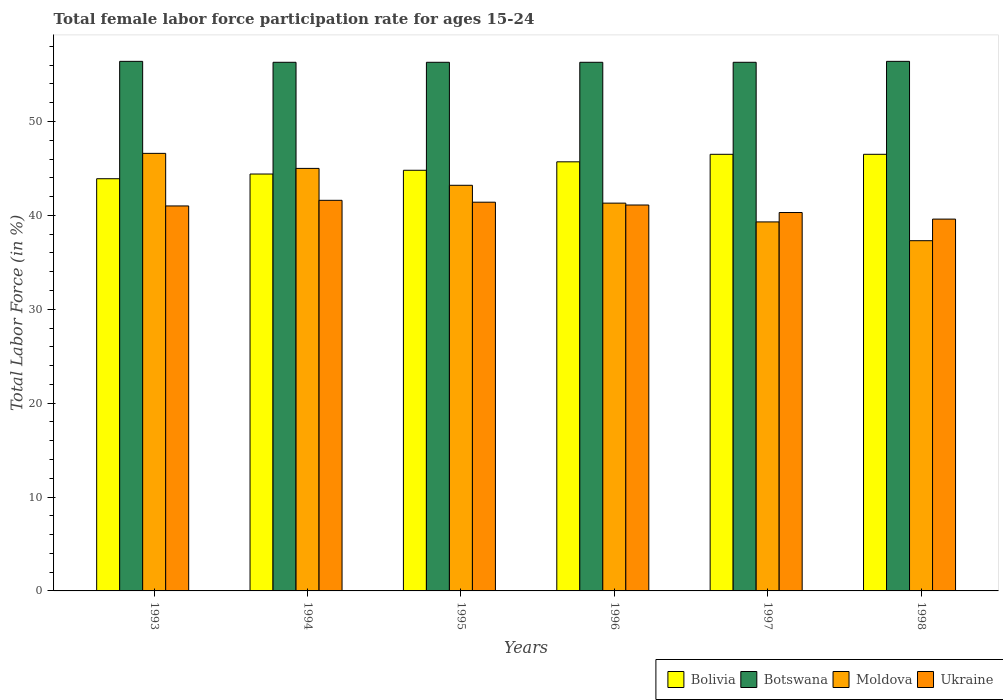How many bars are there on the 4th tick from the left?
Make the answer very short. 4. What is the female labor force participation rate in Ukraine in 1998?
Your response must be concise. 39.6. Across all years, what is the maximum female labor force participation rate in Moldova?
Provide a short and direct response. 46.6. Across all years, what is the minimum female labor force participation rate in Ukraine?
Your answer should be compact. 39.6. What is the total female labor force participation rate in Ukraine in the graph?
Offer a very short reply. 245. What is the difference between the female labor force participation rate in Bolivia in 1998 and the female labor force participation rate in Botswana in 1994?
Make the answer very short. -9.8. What is the average female labor force participation rate in Botswana per year?
Your answer should be compact. 56.33. In the year 1993, what is the difference between the female labor force participation rate in Bolivia and female labor force participation rate in Botswana?
Keep it short and to the point. -12.5. What is the ratio of the female labor force participation rate in Bolivia in 1993 to that in 1998?
Ensure brevity in your answer.  0.94. Is the female labor force participation rate in Ukraine in 1994 less than that in 1995?
Your response must be concise. No. Is the difference between the female labor force participation rate in Bolivia in 1995 and 1996 greater than the difference between the female labor force participation rate in Botswana in 1995 and 1996?
Your response must be concise. No. What is the difference between the highest and the second highest female labor force participation rate in Moldova?
Offer a terse response. 1.6. What is the difference between the highest and the lowest female labor force participation rate in Bolivia?
Offer a terse response. 2.6. Is the sum of the female labor force participation rate in Botswana in 1994 and 1998 greater than the maximum female labor force participation rate in Ukraine across all years?
Ensure brevity in your answer.  Yes. What does the 3rd bar from the left in 1993 represents?
Keep it short and to the point. Moldova. What does the 3rd bar from the right in 1996 represents?
Offer a terse response. Botswana. Is it the case that in every year, the sum of the female labor force participation rate in Botswana and female labor force participation rate in Moldova is greater than the female labor force participation rate in Ukraine?
Your answer should be very brief. Yes. How many bars are there?
Your answer should be very brief. 24. Are all the bars in the graph horizontal?
Your response must be concise. No. How many years are there in the graph?
Ensure brevity in your answer.  6. What is the title of the graph?
Provide a short and direct response. Total female labor force participation rate for ages 15-24. What is the label or title of the X-axis?
Provide a succinct answer. Years. What is the label or title of the Y-axis?
Provide a succinct answer. Total Labor Force (in %). What is the Total Labor Force (in %) of Bolivia in 1993?
Your answer should be very brief. 43.9. What is the Total Labor Force (in %) of Botswana in 1993?
Keep it short and to the point. 56.4. What is the Total Labor Force (in %) of Moldova in 1993?
Your answer should be compact. 46.6. What is the Total Labor Force (in %) of Bolivia in 1994?
Ensure brevity in your answer.  44.4. What is the Total Labor Force (in %) of Botswana in 1994?
Provide a short and direct response. 56.3. What is the Total Labor Force (in %) in Ukraine in 1994?
Keep it short and to the point. 41.6. What is the Total Labor Force (in %) in Bolivia in 1995?
Offer a very short reply. 44.8. What is the Total Labor Force (in %) of Botswana in 1995?
Give a very brief answer. 56.3. What is the Total Labor Force (in %) of Moldova in 1995?
Provide a succinct answer. 43.2. What is the Total Labor Force (in %) of Ukraine in 1995?
Your answer should be compact. 41.4. What is the Total Labor Force (in %) of Bolivia in 1996?
Make the answer very short. 45.7. What is the Total Labor Force (in %) in Botswana in 1996?
Provide a short and direct response. 56.3. What is the Total Labor Force (in %) in Moldova in 1996?
Make the answer very short. 41.3. What is the Total Labor Force (in %) in Ukraine in 1996?
Provide a short and direct response. 41.1. What is the Total Labor Force (in %) of Bolivia in 1997?
Your response must be concise. 46.5. What is the Total Labor Force (in %) in Botswana in 1997?
Provide a succinct answer. 56.3. What is the Total Labor Force (in %) in Moldova in 1997?
Your answer should be very brief. 39.3. What is the Total Labor Force (in %) in Ukraine in 1997?
Your answer should be compact. 40.3. What is the Total Labor Force (in %) in Bolivia in 1998?
Offer a very short reply. 46.5. What is the Total Labor Force (in %) in Botswana in 1998?
Give a very brief answer. 56.4. What is the Total Labor Force (in %) of Moldova in 1998?
Keep it short and to the point. 37.3. What is the Total Labor Force (in %) in Ukraine in 1998?
Offer a terse response. 39.6. Across all years, what is the maximum Total Labor Force (in %) in Bolivia?
Your answer should be compact. 46.5. Across all years, what is the maximum Total Labor Force (in %) of Botswana?
Provide a short and direct response. 56.4. Across all years, what is the maximum Total Labor Force (in %) of Moldova?
Your answer should be compact. 46.6. Across all years, what is the maximum Total Labor Force (in %) in Ukraine?
Provide a short and direct response. 41.6. Across all years, what is the minimum Total Labor Force (in %) of Bolivia?
Give a very brief answer. 43.9. Across all years, what is the minimum Total Labor Force (in %) of Botswana?
Your response must be concise. 56.3. Across all years, what is the minimum Total Labor Force (in %) of Moldova?
Provide a succinct answer. 37.3. Across all years, what is the minimum Total Labor Force (in %) of Ukraine?
Your answer should be compact. 39.6. What is the total Total Labor Force (in %) in Bolivia in the graph?
Keep it short and to the point. 271.8. What is the total Total Labor Force (in %) in Botswana in the graph?
Keep it short and to the point. 338. What is the total Total Labor Force (in %) of Moldova in the graph?
Provide a short and direct response. 252.7. What is the total Total Labor Force (in %) in Ukraine in the graph?
Provide a succinct answer. 245. What is the difference between the Total Labor Force (in %) of Botswana in 1993 and that in 1994?
Make the answer very short. 0.1. What is the difference between the Total Labor Force (in %) in Moldova in 1993 and that in 1994?
Your response must be concise. 1.6. What is the difference between the Total Labor Force (in %) of Moldova in 1993 and that in 1995?
Your answer should be compact. 3.4. What is the difference between the Total Labor Force (in %) of Botswana in 1993 and that in 1996?
Keep it short and to the point. 0.1. What is the difference between the Total Labor Force (in %) in Moldova in 1993 and that in 1996?
Make the answer very short. 5.3. What is the difference between the Total Labor Force (in %) of Bolivia in 1993 and that in 1997?
Keep it short and to the point. -2.6. What is the difference between the Total Labor Force (in %) in Botswana in 1993 and that in 1997?
Offer a terse response. 0.1. What is the difference between the Total Labor Force (in %) in Moldova in 1993 and that in 1997?
Your response must be concise. 7.3. What is the difference between the Total Labor Force (in %) in Botswana in 1993 and that in 1998?
Provide a succinct answer. 0. What is the difference between the Total Labor Force (in %) of Ukraine in 1993 and that in 1998?
Your answer should be very brief. 1.4. What is the difference between the Total Labor Force (in %) of Bolivia in 1994 and that in 1995?
Ensure brevity in your answer.  -0.4. What is the difference between the Total Labor Force (in %) of Botswana in 1994 and that in 1995?
Provide a succinct answer. 0. What is the difference between the Total Labor Force (in %) of Moldova in 1994 and that in 1995?
Offer a very short reply. 1.8. What is the difference between the Total Labor Force (in %) of Botswana in 1994 and that in 1996?
Provide a succinct answer. 0. What is the difference between the Total Labor Force (in %) of Moldova in 1994 and that in 1996?
Your response must be concise. 3.7. What is the difference between the Total Labor Force (in %) of Ukraine in 1994 and that in 1996?
Offer a terse response. 0.5. What is the difference between the Total Labor Force (in %) of Moldova in 1994 and that in 1997?
Provide a succinct answer. 5.7. What is the difference between the Total Labor Force (in %) of Ukraine in 1994 and that in 1997?
Offer a very short reply. 1.3. What is the difference between the Total Labor Force (in %) in Bolivia in 1994 and that in 1998?
Your response must be concise. -2.1. What is the difference between the Total Labor Force (in %) in Botswana in 1994 and that in 1998?
Make the answer very short. -0.1. What is the difference between the Total Labor Force (in %) in Moldova in 1994 and that in 1998?
Make the answer very short. 7.7. What is the difference between the Total Labor Force (in %) in Ukraine in 1994 and that in 1998?
Provide a short and direct response. 2. What is the difference between the Total Labor Force (in %) in Moldova in 1995 and that in 1996?
Offer a terse response. 1.9. What is the difference between the Total Labor Force (in %) of Bolivia in 1995 and that in 1997?
Keep it short and to the point. -1.7. What is the difference between the Total Labor Force (in %) in Ukraine in 1995 and that in 1997?
Your response must be concise. 1.1. What is the difference between the Total Labor Force (in %) of Bolivia in 1995 and that in 1998?
Give a very brief answer. -1.7. What is the difference between the Total Labor Force (in %) of Moldova in 1995 and that in 1998?
Provide a succinct answer. 5.9. What is the difference between the Total Labor Force (in %) of Bolivia in 1996 and that in 1997?
Give a very brief answer. -0.8. What is the difference between the Total Labor Force (in %) in Botswana in 1996 and that in 1997?
Offer a terse response. 0. What is the difference between the Total Labor Force (in %) in Moldova in 1996 and that in 1997?
Offer a very short reply. 2. What is the difference between the Total Labor Force (in %) of Bolivia in 1996 and that in 1998?
Your answer should be compact. -0.8. What is the difference between the Total Labor Force (in %) in Moldova in 1996 and that in 1998?
Make the answer very short. 4. What is the difference between the Total Labor Force (in %) in Ukraine in 1996 and that in 1998?
Your answer should be compact. 1.5. What is the difference between the Total Labor Force (in %) in Bolivia in 1997 and that in 1998?
Make the answer very short. 0. What is the difference between the Total Labor Force (in %) in Botswana in 1997 and that in 1998?
Offer a terse response. -0.1. What is the difference between the Total Labor Force (in %) of Moldova in 1997 and that in 1998?
Make the answer very short. 2. What is the difference between the Total Labor Force (in %) in Bolivia in 1993 and the Total Labor Force (in %) in Moldova in 1994?
Provide a succinct answer. -1.1. What is the difference between the Total Labor Force (in %) in Botswana in 1993 and the Total Labor Force (in %) in Ukraine in 1994?
Ensure brevity in your answer.  14.8. What is the difference between the Total Labor Force (in %) in Moldova in 1993 and the Total Labor Force (in %) in Ukraine in 1994?
Provide a succinct answer. 5. What is the difference between the Total Labor Force (in %) in Bolivia in 1993 and the Total Labor Force (in %) in Botswana in 1995?
Offer a very short reply. -12.4. What is the difference between the Total Labor Force (in %) in Botswana in 1993 and the Total Labor Force (in %) in Moldova in 1995?
Give a very brief answer. 13.2. What is the difference between the Total Labor Force (in %) of Botswana in 1993 and the Total Labor Force (in %) of Ukraine in 1995?
Make the answer very short. 15. What is the difference between the Total Labor Force (in %) of Bolivia in 1993 and the Total Labor Force (in %) of Ukraine in 1996?
Keep it short and to the point. 2.8. What is the difference between the Total Labor Force (in %) in Botswana in 1993 and the Total Labor Force (in %) in Moldova in 1996?
Make the answer very short. 15.1. What is the difference between the Total Labor Force (in %) of Moldova in 1993 and the Total Labor Force (in %) of Ukraine in 1996?
Keep it short and to the point. 5.5. What is the difference between the Total Labor Force (in %) of Bolivia in 1993 and the Total Labor Force (in %) of Botswana in 1997?
Give a very brief answer. -12.4. What is the difference between the Total Labor Force (in %) in Bolivia in 1993 and the Total Labor Force (in %) in Moldova in 1997?
Keep it short and to the point. 4.6. What is the difference between the Total Labor Force (in %) of Bolivia in 1993 and the Total Labor Force (in %) of Ukraine in 1997?
Keep it short and to the point. 3.6. What is the difference between the Total Labor Force (in %) of Botswana in 1993 and the Total Labor Force (in %) of Moldova in 1997?
Ensure brevity in your answer.  17.1. What is the difference between the Total Labor Force (in %) in Botswana in 1993 and the Total Labor Force (in %) in Ukraine in 1997?
Ensure brevity in your answer.  16.1. What is the difference between the Total Labor Force (in %) in Bolivia in 1993 and the Total Labor Force (in %) in Botswana in 1998?
Your response must be concise. -12.5. What is the difference between the Total Labor Force (in %) in Bolivia in 1993 and the Total Labor Force (in %) in Ukraine in 1998?
Your answer should be compact. 4.3. What is the difference between the Total Labor Force (in %) in Botswana in 1993 and the Total Labor Force (in %) in Moldova in 1998?
Keep it short and to the point. 19.1. What is the difference between the Total Labor Force (in %) in Botswana in 1993 and the Total Labor Force (in %) in Ukraine in 1998?
Offer a very short reply. 16.8. What is the difference between the Total Labor Force (in %) of Moldova in 1993 and the Total Labor Force (in %) of Ukraine in 1998?
Provide a succinct answer. 7. What is the difference between the Total Labor Force (in %) in Bolivia in 1994 and the Total Labor Force (in %) in Moldova in 1995?
Keep it short and to the point. 1.2. What is the difference between the Total Labor Force (in %) in Bolivia in 1994 and the Total Labor Force (in %) in Botswana in 1996?
Offer a very short reply. -11.9. What is the difference between the Total Labor Force (in %) in Bolivia in 1994 and the Total Labor Force (in %) in Moldova in 1996?
Provide a succinct answer. 3.1. What is the difference between the Total Labor Force (in %) of Botswana in 1994 and the Total Labor Force (in %) of Moldova in 1996?
Provide a succinct answer. 15. What is the difference between the Total Labor Force (in %) of Botswana in 1994 and the Total Labor Force (in %) of Ukraine in 1996?
Your response must be concise. 15.2. What is the difference between the Total Labor Force (in %) in Bolivia in 1994 and the Total Labor Force (in %) in Ukraine in 1997?
Ensure brevity in your answer.  4.1. What is the difference between the Total Labor Force (in %) of Botswana in 1994 and the Total Labor Force (in %) of Moldova in 1997?
Offer a very short reply. 17. What is the difference between the Total Labor Force (in %) of Moldova in 1994 and the Total Labor Force (in %) of Ukraine in 1997?
Provide a succinct answer. 4.7. What is the difference between the Total Labor Force (in %) in Bolivia in 1994 and the Total Labor Force (in %) in Moldova in 1998?
Your answer should be very brief. 7.1. What is the difference between the Total Labor Force (in %) in Bolivia in 1994 and the Total Labor Force (in %) in Ukraine in 1998?
Ensure brevity in your answer.  4.8. What is the difference between the Total Labor Force (in %) of Botswana in 1994 and the Total Labor Force (in %) of Moldova in 1998?
Ensure brevity in your answer.  19. What is the difference between the Total Labor Force (in %) in Moldova in 1994 and the Total Labor Force (in %) in Ukraine in 1998?
Your answer should be compact. 5.4. What is the difference between the Total Labor Force (in %) of Bolivia in 1995 and the Total Labor Force (in %) of Moldova in 1996?
Provide a succinct answer. 3.5. What is the difference between the Total Labor Force (in %) in Bolivia in 1995 and the Total Labor Force (in %) in Ukraine in 1996?
Give a very brief answer. 3.7. What is the difference between the Total Labor Force (in %) in Botswana in 1995 and the Total Labor Force (in %) in Moldova in 1996?
Your answer should be very brief. 15. What is the difference between the Total Labor Force (in %) of Bolivia in 1995 and the Total Labor Force (in %) of Moldova in 1997?
Give a very brief answer. 5.5. What is the difference between the Total Labor Force (in %) of Bolivia in 1995 and the Total Labor Force (in %) of Ukraine in 1997?
Provide a succinct answer. 4.5. What is the difference between the Total Labor Force (in %) of Botswana in 1995 and the Total Labor Force (in %) of Moldova in 1997?
Offer a terse response. 17. What is the difference between the Total Labor Force (in %) in Bolivia in 1995 and the Total Labor Force (in %) in Botswana in 1998?
Offer a terse response. -11.6. What is the difference between the Total Labor Force (in %) in Bolivia in 1995 and the Total Labor Force (in %) in Moldova in 1998?
Your answer should be compact. 7.5. What is the difference between the Total Labor Force (in %) in Botswana in 1995 and the Total Labor Force (in %) in Moldova in 1998?
Provide a short and direct response. 19. What is the difference between the Total Labor Force (in %) of Botswana in 1995 and the Total Labor Force (in %) of Ukraine in 1998?
Provide a short and direct response. 16.7. What is the difference between the Total Labor Force (in %) in Bolivia in 1996 and the Total Labor Force (in %) in Moldova in 1997?
Offer a terse response. 6.4. What is the difference between the Total Labor Force (in %) of Bolivia in 1996 and the Total Labor Force (in %) of Ukraine in 1997?
Your response must be concise. 5.4. What is the difference between the Total Labor Force (in %) in Botswana in 1996 and the Total Labor Force (in %) in Ukraine in 1997?
Make the answer very short. 16. What is the difference between the Total Labor Force (in %) of Moldova in 1996 and the Total Labor Force (in %) of Ukraine in 1997?
Your response must be concise. 1. What is the difference between the Total Labor Force (in %) in Bolivia in 1996 and the Total Labor Force (in %) in Botswana in 1998?
Your answer should be very brief. -10.7. What is the difference between the Total Labor Force (in %) of Bolivia in 1996 and the Total Labor Force (in %) of Moldova in 1998?
Your answer should be very brief. 8.4. What is the difference between the Total Labor Force (in %) in Bolivia in 1996 and the Total Labor Force (in %) in Ukraine in 1998?
Provide a short and direct response. 6.1. What is the difference between the Total Labor Force (in %) in Botswana in 1996 and the Total Labor Force (in %) in Ukraine in 1998?
Offer a terse response. 16.7. What is the difference between the Total Labor Force (in %) of Moldova in 1996 and the Total Labor Force (in %) of Ukraine in 1998?
Offer a terse response. 1.7. What is the difference between the Total Labor Force (in %) of Bolivia in 1997 and the Total Labor Force (in %) of Moldova in 1998?
Provide a succinct answer. 9.2. What is the difference between the Total Labor Force (in %) in Bolivia in 1997 and the Total Labor Force (in %) in Ukraine in 1998?
Make the answer very short. 6.9. What is the difference between the Total Labor Force (in %) in Botswana in 1997 and the Total Labor Force (in %) in Moldova in 1998?
Provide a succinct answer. 19. What is the difference between the Total Labor Force (in %) in Botswana in 1997 and the Total Labor Force (in %) in Ukraine in 1998?
Offer a very short reply. 16.7. What is the difference between the Total Labor Force (in %) in Moldova in 1997 and the Total Labor Force (in %) in Ukraine in 1998?
Your answer should be compact. -0.3. What is the average Total Labor Force (in %) in Bolivia per year?
Offer a terse response. 45.3. What is the average Total Labor Force (in %) in Botswana per year?
Give a very brief answer. 56.33. What is the average Total Labor Force (in %) in Moldova per year?
Offer a very short reply. 42.12. What is the average Total Labor Force (in %) of Ukraine per year?
Provide a succinct answer. 40.83. In the year 1993, what is the difference between the Total Labor Force (in %) in Bolivia and Total Labor Force (in %) in Botswana?
Provide a succinct answer. -12.5. In the year 1993, what is the difference between the Total Labor Force (in %) in Bolivia and Total Labor Force (in %) in Ukraine?
Your answer should be compact. 2.9. In the year 1994, what is the difference between the Total Labor Force (in %) of Bolivia and Total Labor Force (in %) of Botswana?
Provide a short and direct response. -11.9. In the year 1994, what is the difference between the Total Labor Force (in %) in Bolivia and Total Labor Force (in %) in Moldova?
Your response must be concise. -0.6. In the year 1994, what is the difference between the Total Labor Force (in %) in Botswana and Total Labor Force (in %) in Ukraine?
Provide a short and direct response. 14.7. In the year 1995, what is the difference between the Total Labor Force (in %) in Bolivia and Total Labor Force (in %) in Botswana?
Make the answer very short. -11.5. In the year 1995, what is the difference between the Total Labor Force (in %) of Bolivia and Total Labor Force (in %) of Moldova?
Keep it short and to the point. 1.6. In the year 1995, what is the difference between the Total Labor Force (in %) in Botswana and Total Labor Force (in %) in Ukraine?
Ensure brevity in your answer.  14.9. In the year 1995, what is the difference between the Total Labor Force (in %) of Moldova and Total Labor Force (in %) of Ukraine?
Offer a terse response. 1.8. In the year 1996, what is the difference between the Total Labor Force (in %) in Bolivia and Total Labor Force (in %) in Moldova?
Keep it short and to the point. 4.4. In the year 1997, what is the difference between the Total Labor Force (in %) in Bolivia and Total Labor Force (in %) in Botswana?
Offer a terse response. -9.8. In the year 1997, what is the difference between the Total Labor Force (in %) in Bolivia and Total Labor Force (in %) in Moldova?
Make the answer very short. 7.2. In the year 1997, what is the difference between the Total Labor Force (in %) in Bolivia and Total Labor Force (in %) in Ukraine?
Provide a short and direct response. 6.2. In the year 1997, what is the difference between the Total Labor Force (in %) in Botswana and Total Labor Force (in %) in Moldova?
Your response must be concise. 17. In the year 1997, what is the difference between the Total Labor Force (in %) in Botswana and Total Labor Force (in %) in Ukraine?
Give a very brief answer. 16. In the year 1997, what is the difference between the Total Labor Force (in %) of Moldova and Total Labor Force (in %) of Ukraine?
Your answer should be very brief. -1. In the year 1998, what is the difference between the Total Labor Force (in %) in Bolivia and Total Labor Force (in %) in Moldova?
Give a very brief answer. 9.2. In the year 1998, what is the difference between the Total Labor Force (in %) of Moldova and Total Labor Force (in %) of Ukraine?
Provide a short and direct response. -2.3. What is the ratio of the Total Labor Force (in %) in Bolivia in 1993 to that in 1994?
Offer a very short reply. 0.99. What is the ratio of the Total Labor Force (in %) of Moldova in 1993 to that in 1994?
Provide a short and direct response. 1.04. What is the ratio of the Total Labor Force (in %) in Ukraine in 1993 to that in 1994?
Keep it short and to the point. 0.99. What is the ratio of the Total Labor Force (in %) of Bolivia in 1993 to that in 1995?
Give a very brief answer. 0.98. What is the ratio of the Total Labor Force (in %) in Botswana in 1993 to that in 1995?
Offer a very short reply. 1. What is the ratio of the Total Labor Force (in %) of Moldova in 1993 to that in 1995?
Provide a succinct answer. 1.08. What is the ratio of the Total Labor Force (in %) of Ukraine in 1993 to that in 1995?
Offer a terse response. 0.99. What is the ratio of the Total Labor Force (in %) in Bolivia in 1993 to that in 1996?
Give a very brief answer. 0.96. What is the ratio of the Total Labor Force (in %) of Botswana in 1993 to that in 1996?
Offer a terse response. 1. What is the ratio of the Total Labor Force (in %) in Moldova in 1993 to that in 1996?
Your answer should be very brief. 1.13. What is the ratio of the Total Labor Force (in %) in Bolivia in 1993 to that in 1997?
Ensure brevity in your answer.  0.94. What is the ratio of the Total Labor Force (in %) in Botswana in 1993 to that in 1997?
Make the answer very short. 1. What is the ratio of the Total Labor Force (in %) of Moldova in 1993 to that in 1997?
Ensure brevity in your answer.  1.19. What is the ratio of the Total Labor Force (in %) of Ukraine in 1993 to that in 1997?
Ensure brevity in your answer.  1.02. What is the ratio of the Total Labor Force (in %) in Bolivia in 1993 to that in 1998?
Your answer should be compact. 0.94. What is the ratio of the Total Labor Force (in %) of Moldova in 1993 to that in 1998?
Keep it short and to the point. 1.25. What is the ratio of the Total Labor Force (in %) in Ukraine in 1993 to that in 1998?
Offer a terse response. 1.04. What is the ratio of the Total Labor Force (in %) in Bolivia in 1994 to that in 1995?
Offer a terse response. 0.99. What is the ratio of the Total Labor Force (in %) in Botswana in 1994 to that in 1995?
Provide a succinct answer. 1. What is the ratio of the Total Labor Force (in %) of Moldova in 1994 to that in 1995?
Give a very brief answer. 1.04. What is the ratio of the Total Labor Force (in %) of Ukraine in 1994 to that in 1995?
Provide a succinct answer. 1. What is the ratio of the Total Labor Force (in %) of Bolivia in 1994 to that in 1996?
Provide a short and direct response. 0.97. What is the ratio of the Total Labor Force (in %) of Botswana in 1994 to that in 1996?
Give a very brief answer. 1. What is the ratio of the Total Labor Force (in %) of Moldova in 1994 to that in 1996?
Make the answer very short. 1.09. What is the ratio of the Total Labor Force (in %) of Ukraine in 1994 to that in 1996?
Your answer should be very brief. 1.01. What is the ratio of the Total Labor Force (in %) in Bolivia in 1994 to that in 1997?
Offer a very short reply. 0.95. What is the ratio of the Total Labor Force (in %) of Moldova in 1994 to that in 1997?
Provide a succinct answer. 1.15. What is the ratio of the Total Labor Force (in %) of Ukraine in 1994 to that in 1997?
Ensure brevity in your answer.  1.03. What is the ratio of the Total Labor Force (in %) of Bolivia in 1994 to that in 1998?
Offer a very short reply. 0.95. What is the ratio of the Total Labor Force (in %) of Botswana in 1994 to that in 1998?
Ensure brevity in your answer.  1. What is the ratio of the Total Labor Force (in %) of Moldova in 1994 to that in 1998?
Offer a very short reply. 1.21. What is the ratio of the Total Labor Force (in %) of Ukraine in 1994 to that in 1998?
Your answer should be very brief. 1.05. What is the ratio of the Total Labor Force (in %) in Bolivia in 1995 to that in 1996?
Ensure brevity in your answer.  0.98. What is the ratio of the Total Labor Force (in %) in Botswana in 1995 to that in 1996?
Your response must be concise. 1. What is the ratio of the Total Labor Force (in %) in Moldova in 1995 to that in 1996?
Provide a succinct answer. 1.05. What is the ratio of the Total Labor Force (in %) of Ukraine in 1995 to that in 1996?
Your response must be concise. 1.01. What is the ratio of the Total Labor Force (in %) of Bolivia in 1995 to that in 1997?
Make the answer very short. 0.96. What is the ratio of the Total Labor Force (in %) of Moldova in 1995 to that in 1997?
Provide a short and direct response. 1.1. What is the ratio of the Total Labor Force (in %) in Ukraine in 1995 to that in 1997?
Provide a succinct answer. 1.03. What is the ratio of the Total Labor Force (in %) of Bolivia in 1995 to that in 1998?
Your response must be concise. 0.96. What is the ratio of the Total Labor Force (in %) of Botswana in 1995 to that in 1998?
Your answer should be very brief. 1. What is the ratio of the Total Labor Force (in %) in Moldova in 1995 to that in 1998?
Offer a very short reply. 1.16. What is the ratio of the Total Labor Force (in %) in Ukraine in 1995 to that in 1998?
Ensure brevity in your answer.  1.05. What is the ratio of the Total Labor Force (in %) in Bolivia in 1996 to that in 1997?
Keep it short and to the point. 0.98. What is the ratio of the Total Labor Force (in %) of Botswana in 1996 to that in 1997?
Your answer should be compact. 1. What is the ratio of the Total Labor Force (in %) in Moldova in 1996 to that in 1997?
Your answer should be compact. 1.05. What is the ratio of the Total Labor Force (in %) in Ukraine in 1996 to that in 1997?
Provide a short and direct response. 1.02. What is the ratio of the Total Labor Force (in %) in Bolivia in 1996 to that in 1998?
Provide a succinct answer. 0.98. What is the ratio of the Total Labor Force (in %) of Botswana in 1996 to that in 1998?
Keep it short and to the point. 1. What is the ratio of the Total Labor Force (in %) of Moldova in 1996 to that in 1998?
Offer a very short reply. 1.11. What is the ratio of the Total Labor Force (in %) of Ukraine in 1996 to that in 1998?
Offer a very short reply. 1.04. What is the ratio of the Total Labor Force (in %) of Bolivia in 1997 to that in 1998?
Give a very brief answer. 1. What is the ratio of the Total Labor Force (in %) in Moldova in 1997 to that in 1998?
Keep it short and to the point. 1.05. What is the ratio of the Total Labor Force (in %) in Ukraine in 1997 to that in 1998?
Offer a terse response. 1.02. What is the difference between the highest and the second highest Total Labor Force (in %) of Ukraine?
Provide a short and direct response. 0.2. What is the difference between the highest and the lowest Total Labor Force (in %) of Bolivia?
Offer a very short reply. 2.6. What is the difference between the highest and the lowest Total Labor Force (in %) in Moldova?
Your answer should be very brief. 9.3. What is the difference between the highest and the lowest Total Labor Force (in %) of Ukraine?
Ensure brevity in your answer.  2. 